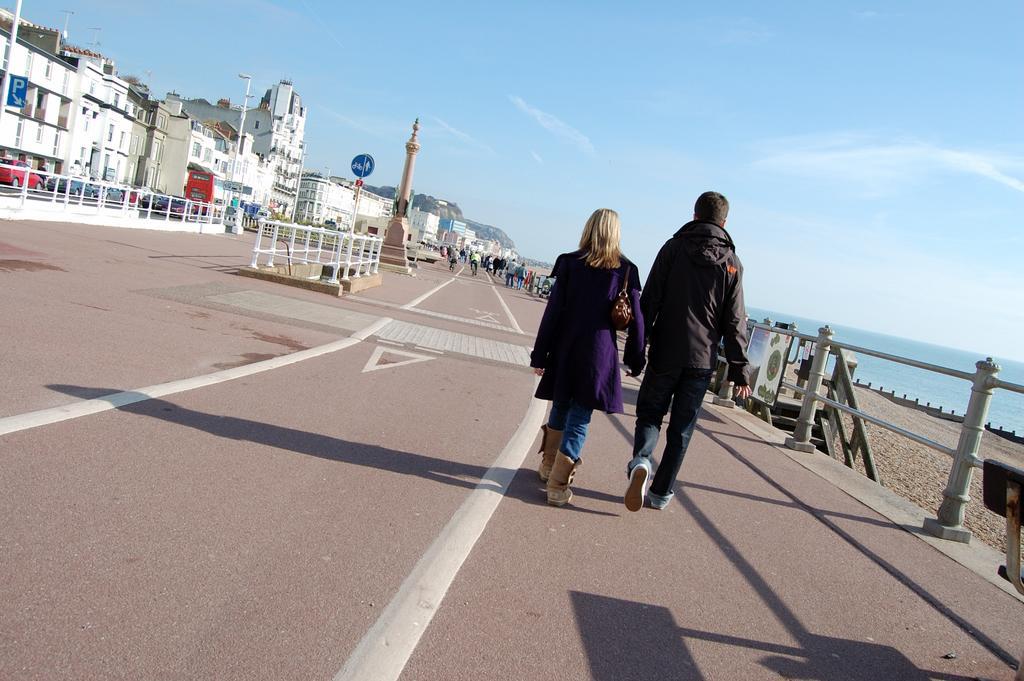In one or two sentences, can you explain what this image depicts? This image consists of two persons walking on the road. At the bottom, there is a road. On the right, there is a railing. On the left, we can see many buildings. At the top, there are clouds in the sky. On the extreme right, there is water. 